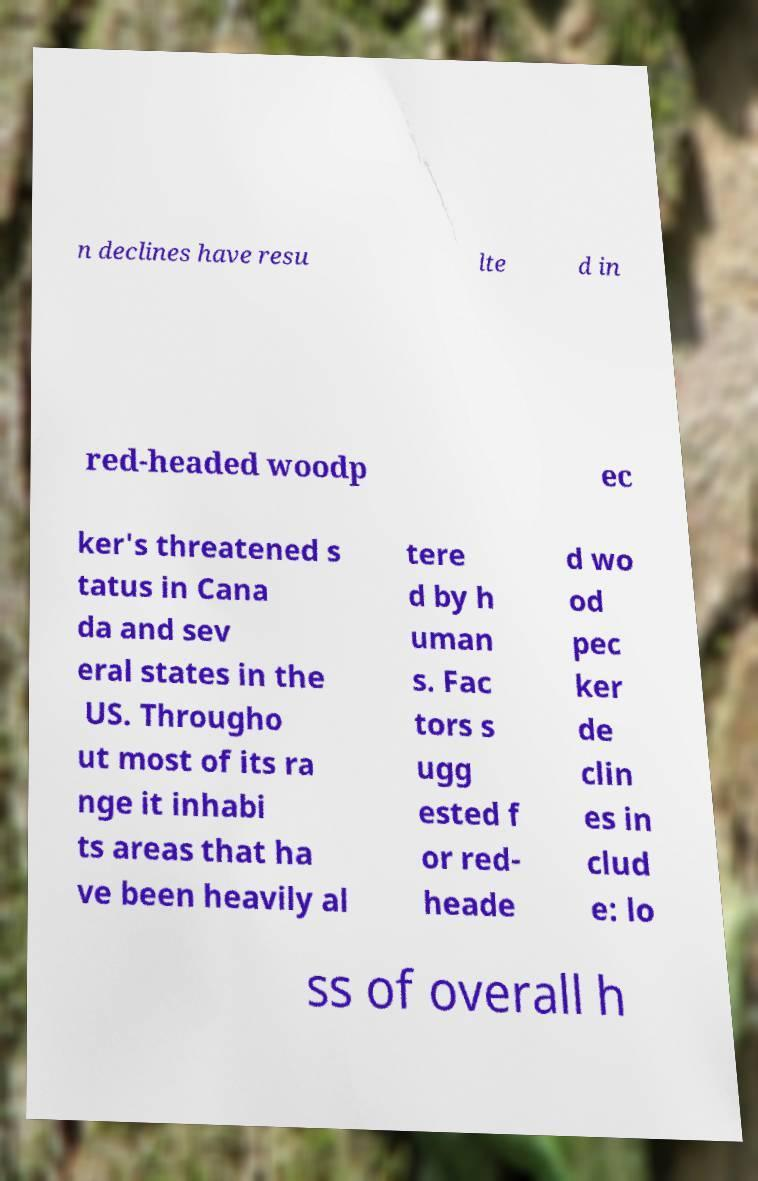Can you accurately transcribe the text from the provided image for me? n declines have resu lte d in red-headed woodp ec ker's threatened s tatus in Cana da and sev eral states in the US. Througho ut most of its ra nge it inhabi ts areas that ha ve been heavily al tere d by h uman s. Fac tors s ugg ested f or red- heade d wo od pec ker de clin es in clud e: lo ss of overall h 